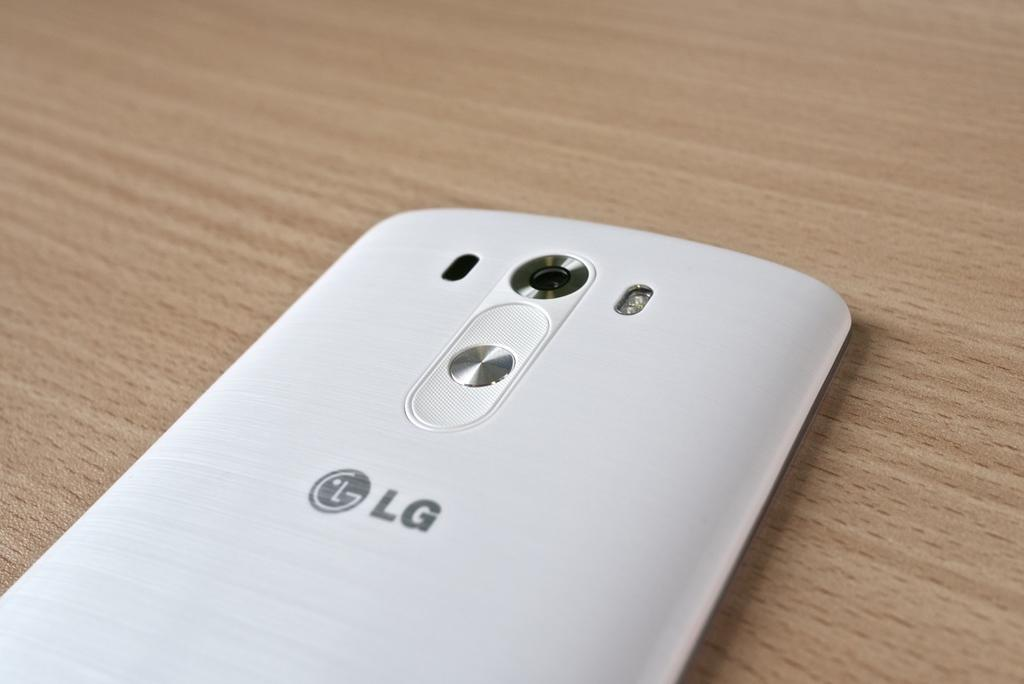<image>
Give a short and clear explanation of the subsequent image. The back of a phone made by the brand LG in white. 